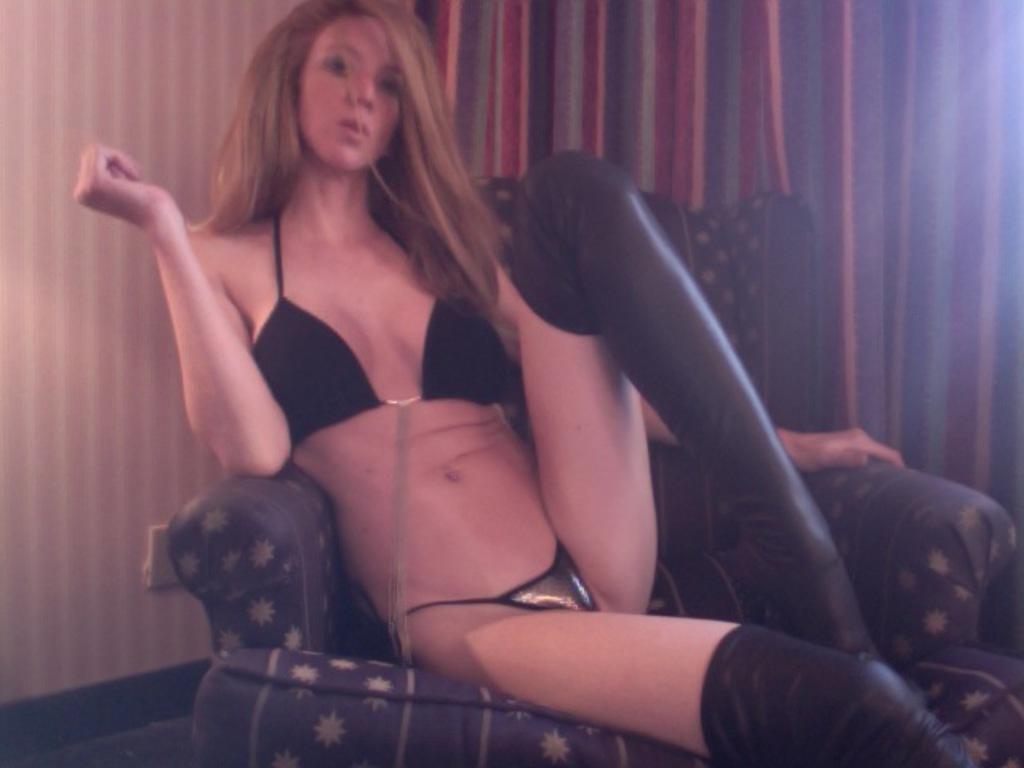Who is present in the image? There is a woman in the image. What is the woman doing in the image? The woman is sitting on a chair. What can be seen in the background of the image? There is a wall and a curtain in the background of the image. What is visible at the bottom of the image? The floor is visible at the bottom of the image. What type of pigs can be seen interacting with the woman in the image? There are no pigs present in the image, and therefore no such interaction can be observed. What effect does the woman's presence have on the company in the image? There is no company present in the image, so it is not possible to determine any effects on a company. 